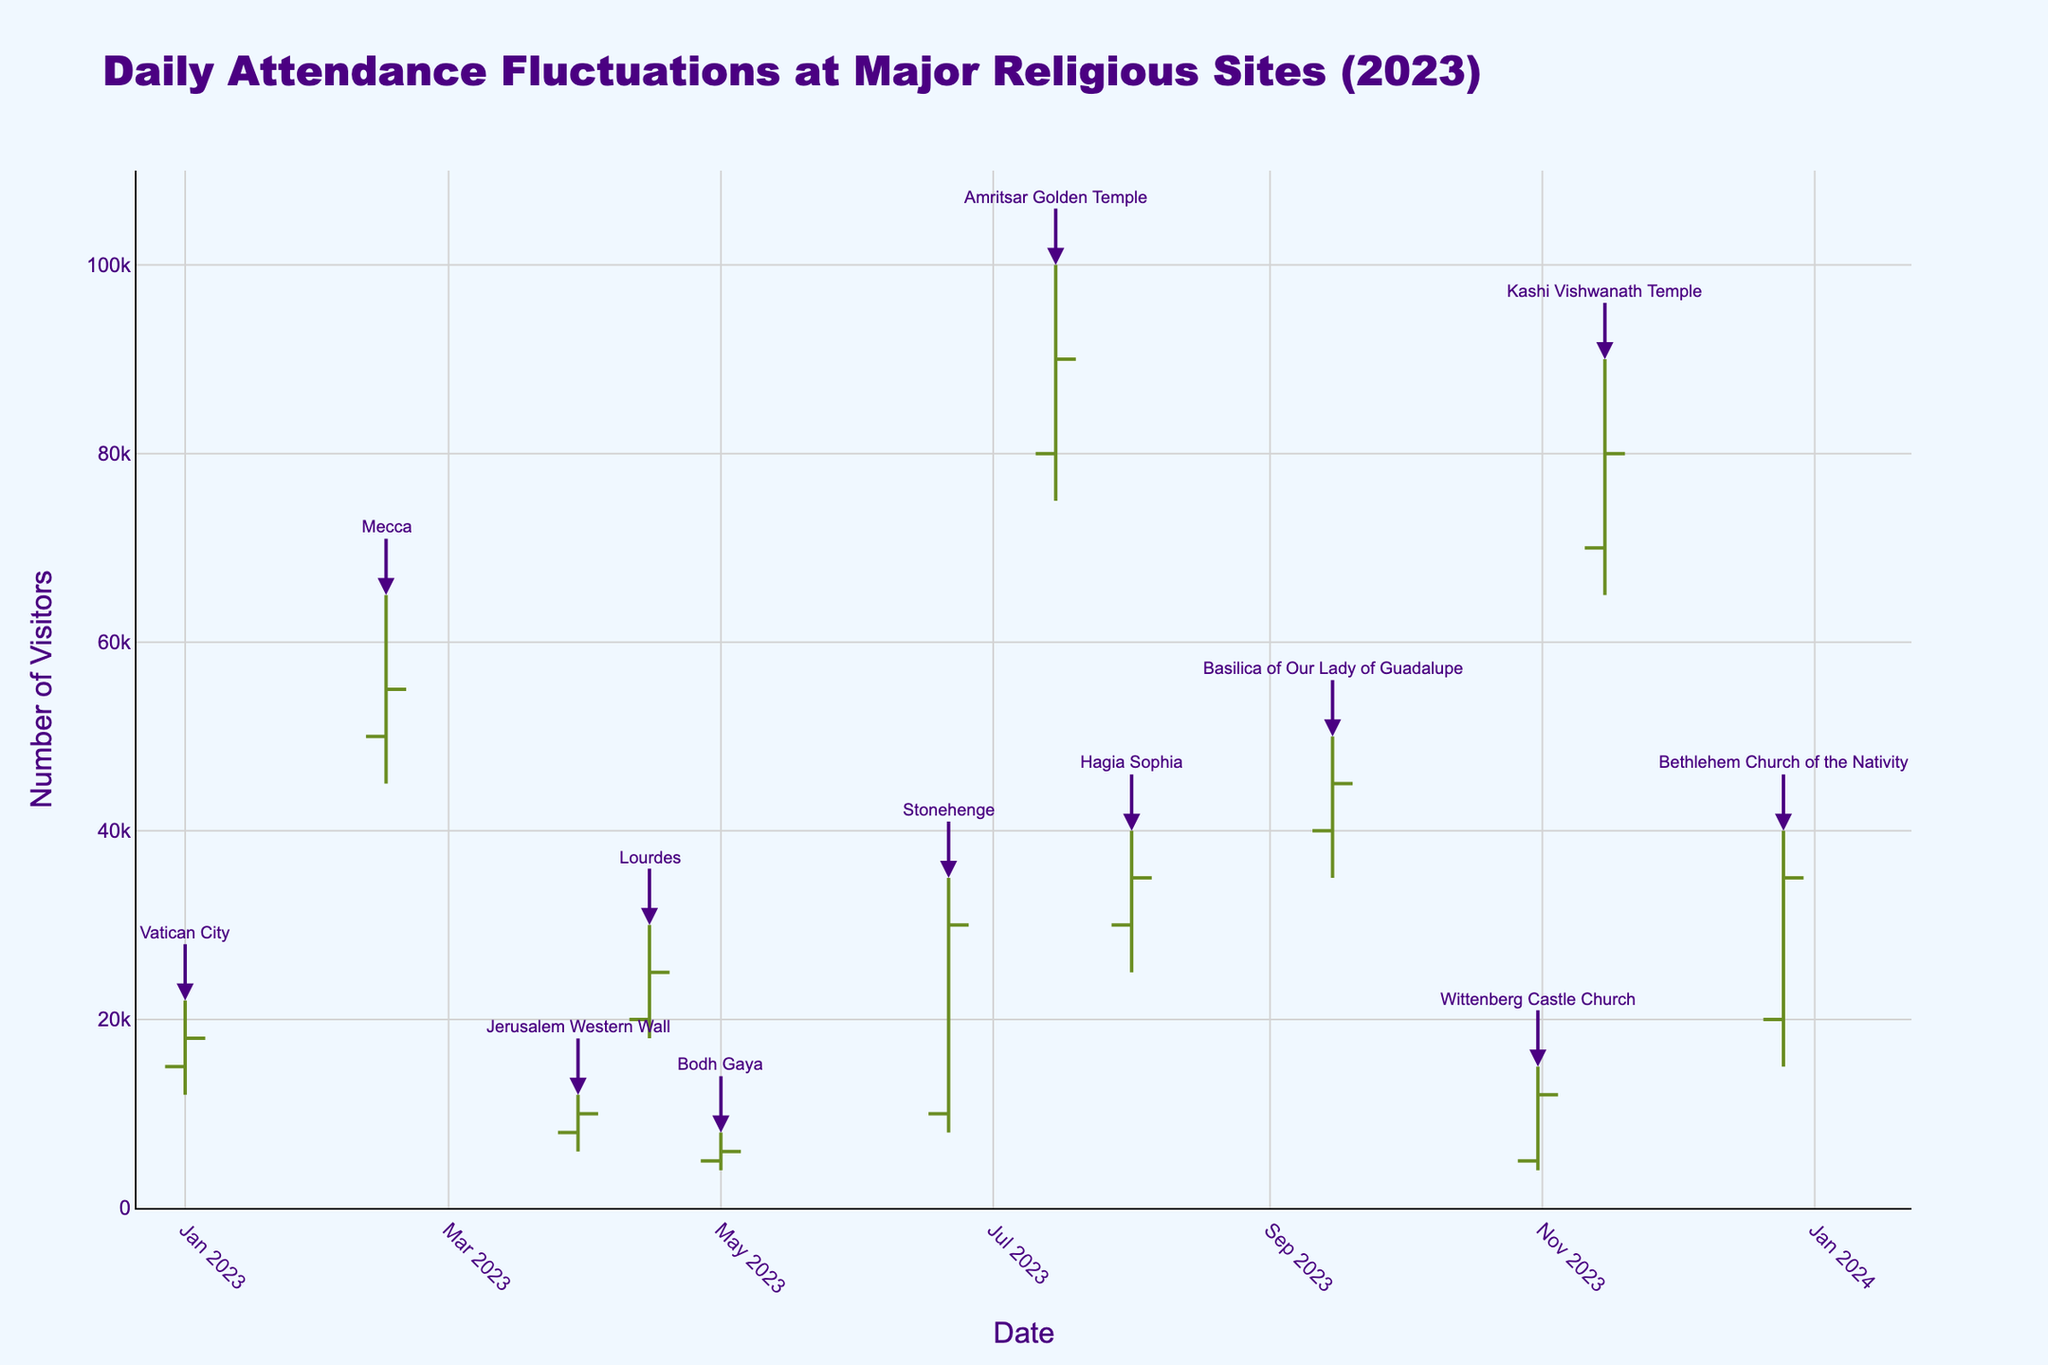What is the title of the figure? The title of the figure is usually displayed prominently at the top of the chart. In this case, the title is "Daily Attendance Fluctuations at Major Religious Sites (2023)."
Answer: Daily Attendance Fluctuations at Major Religious Sites (2023) What is the name of the religious site with the highest recorded attendance? By observing the highest peaks in the OHLC chart, the site with the highest recorded attendance would be the one with the highest "High" value. Here, the peak value is 100,000 for Amritsar Golden Temple.
Answer: Amritsar Golden Temple Which religious site shows the greatest difference between its highest and lowest attendance on the same day? To find this, subtract the "Low" value from the "High" value for each site and compare the results. The greatest difference is for Amritsar Golden Temple (100,000 - 75,000 = 25,000).
Answer: Amritsar Golden Temple What is the range of attendance for Wittenberg Castle Church? The range is the difference between the "High" and "Low" attendance values for Wittenberg Castle Church: 15,000 - 4,000 = 11,000.
Answer: 11,000 Which month shows the highest attendance for the majority of the religious sites? Analyzing the highest attendance in each month, July shows the highest attendance overall, with Amritsar Golden Temple reaching 100,000 visits.
Answer: July How does the attendance trend for Bethlehem Church of the Nativity compare from its opening to closing values? Look at the "Open" and "Close" values for Bethlehem Church of the Nativity: it opens at 20,000 and closes at 35,000, indicating an increasing trend.
Answer: Increasing What is the combined closing attendance for religious sites in April, May, and September? Sum the "Close" values for these months: Lourdes (25,000) + Bodh Gaya (6,000) + Basilica of Our Lady of Guadalupe (45,000) = 76,000.
Answer: 76,000 Which religious site had a peak attendance on the exact date of July 15, 2023? Cross-referencing July 15, 2023, with the dates in the chart, Amritsar Golden Temple had a peak attendance on this date.
Answer: Amritsar Golden Temple What is the overall trend for the attendance of Mecca from its opening to closing value? Mecca opens at 50,000 and closes at 55,000 on its date, indicating a slight increasing trend.
Answer: Increasing 